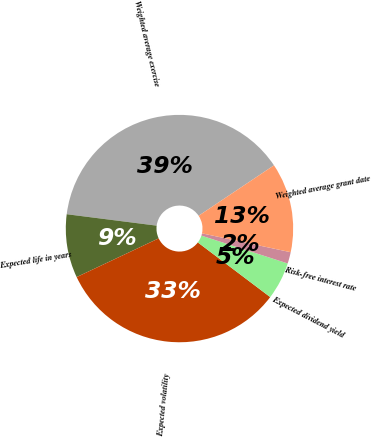<chart> <loc_0><loc_0><loc_500><loc_500><pie_chart><fcel>Weighted average exercise<fcel>Expected life in years<fcel>Expected volatility<fcel>Expected dividend yield<fcel>Risk-free interest rate<fcel>Weighted average grant date<nl><fcel>38.6%<fcel>9.03%<fcel>32.69%<fcel>5.33%<fcel>1.63%<fcel>12.72%<nl></chart> 